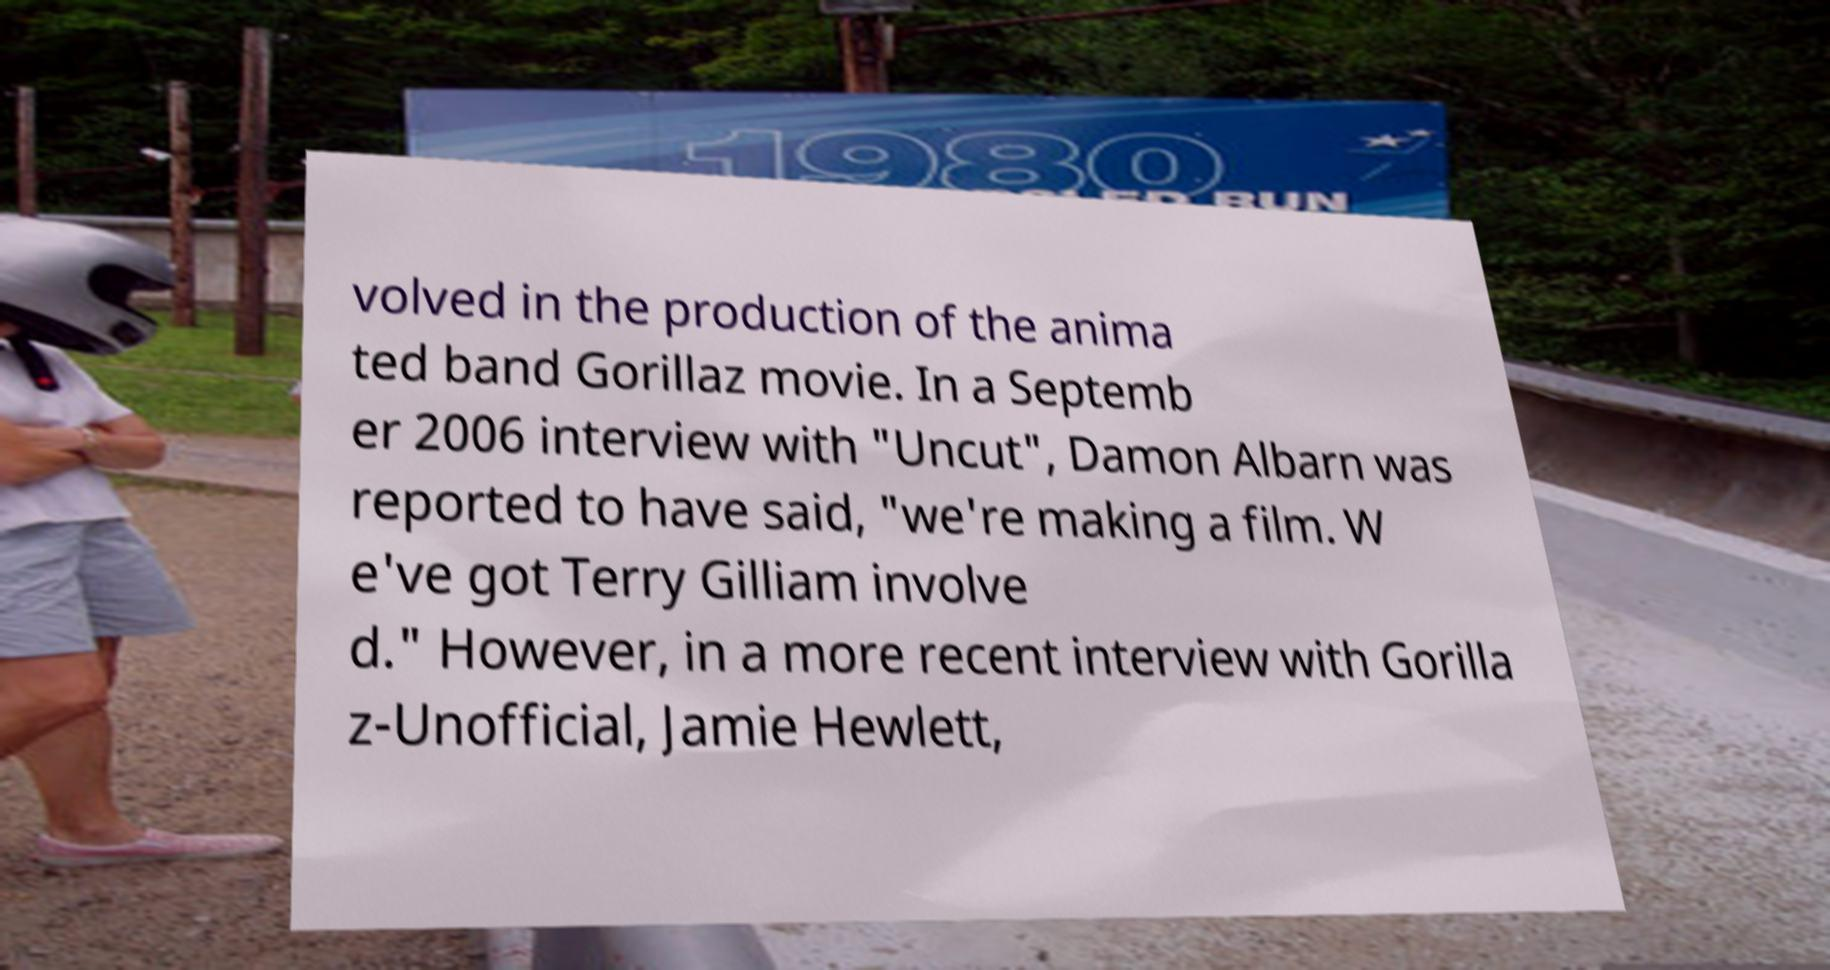Please read and relay the text visible in this image. What does it say? volved in the production of the anima ted band Gorillaz movie. In a Septemb er 2006 interview with "Uncut", Damon Albarn was reported to have said, "we're making a film. W e've got Terry Gilliam involve d." However, in a more recent interview with Gorilla z-Unofficial, Jamie Hewlett, 